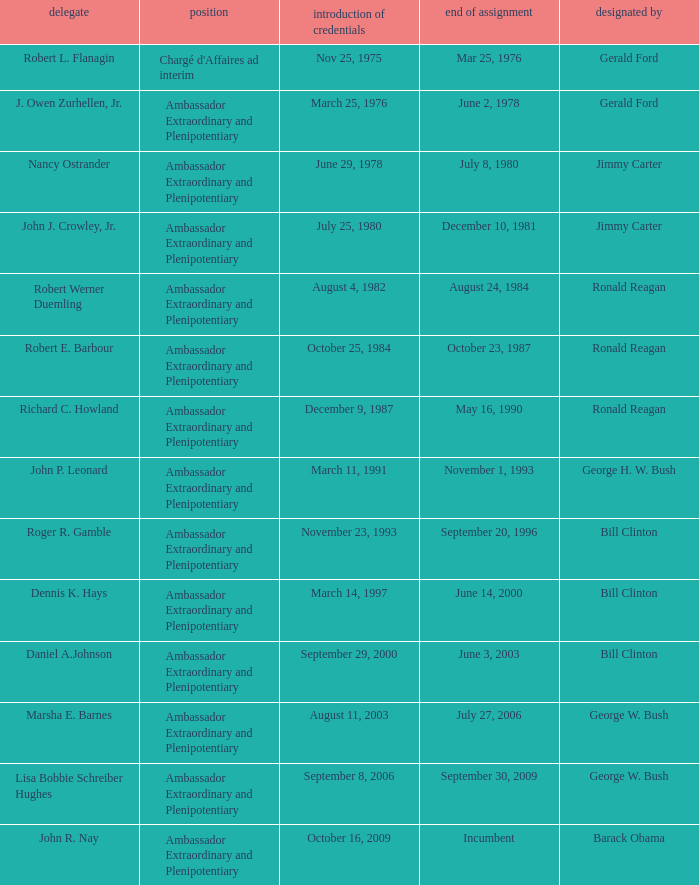What is the Termination of Mission date for Marsha E. Barnes, the Ambassador Extraordinary and Plenipotentiary? July 27, 2006. 